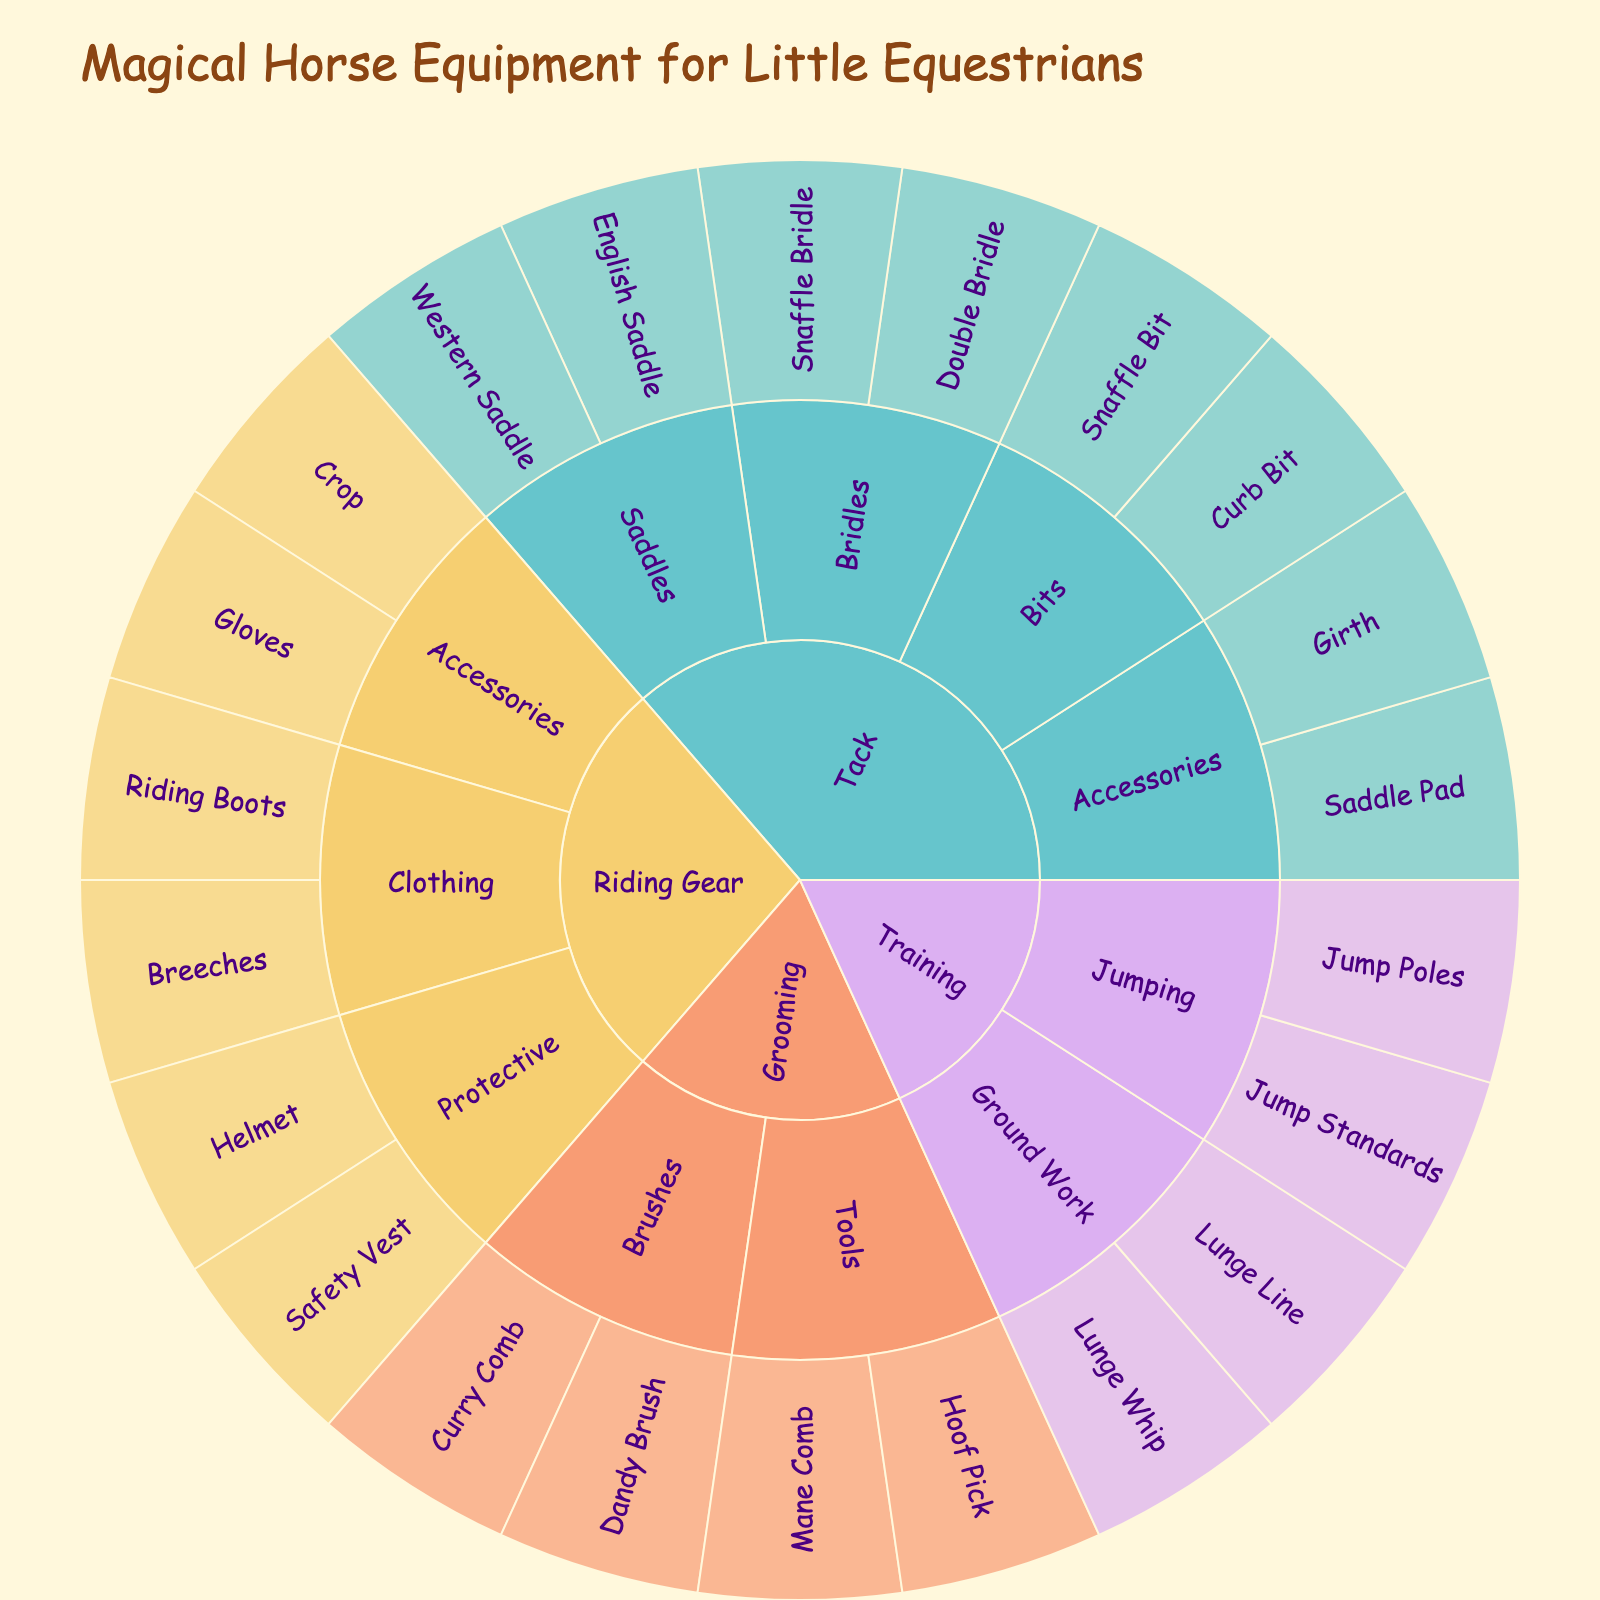What is the title of the sunburst plot? The title is displayed at the top of the sunburst plot in larger and stylized text.
Answer: Magical Horse Equipment for Little Equestrians Which category has the most subcategories? By looking at the different branches originating from each main category, Tack has the most subcategories.
Answer: Tack How many types of Protective gear are listed under Riding Gear? Identify the Riding Gear category, then count the equipment under its Protective subcategory. There are two pieces of equipment: Helmet and Safety Vest.
Answer: 2 Compare the number of equipment items for Ground Work and Jumping under Training. Which has more? Training has two subcategories: Ground Work with Lunge Line and Lunge Whip, and Jumping with Jump Poles and Jump Standards. Each subcategory has two items, so they are equal.
Answer: Equal What equipment falls under the Brushes subcategory in Grooming? Locate the Grooming category, then see the Brushes subcategory which includes Curry Comb and Dandy Brush.
Answer: Curry Comb, Dandy Brush Which category uses the color pink? Identify the predefined color scheme: Grooming uses the color pink.
Answer: Grooming How many different types of bits are listed? Counting the different types of bits under Tack (Snaffle Bit and Curb Bit) leads to a total of two.
Answer: 2 What is the difference in the number of accessories between Riding Gear and Tack? Riding Gear has two accessories: Gloves and Crop. Tack has two accessories: Saddle Pad and Girth, resulting in no difference.
Answer: 0 Are there more saddles or bridles listed under Tack? Under Tack, there are two saddles (English Saddle, Western Saddle) and two bridles (Snaffle Bridle, Double Bridle). They are equal in number.
Answer: Equal What type of Riding Gear is used for Clothing? Check Riding Gear and find Clothing subcategory which includes Breeches and Riding Boots.
Answer: Breeches, Riding Boots 